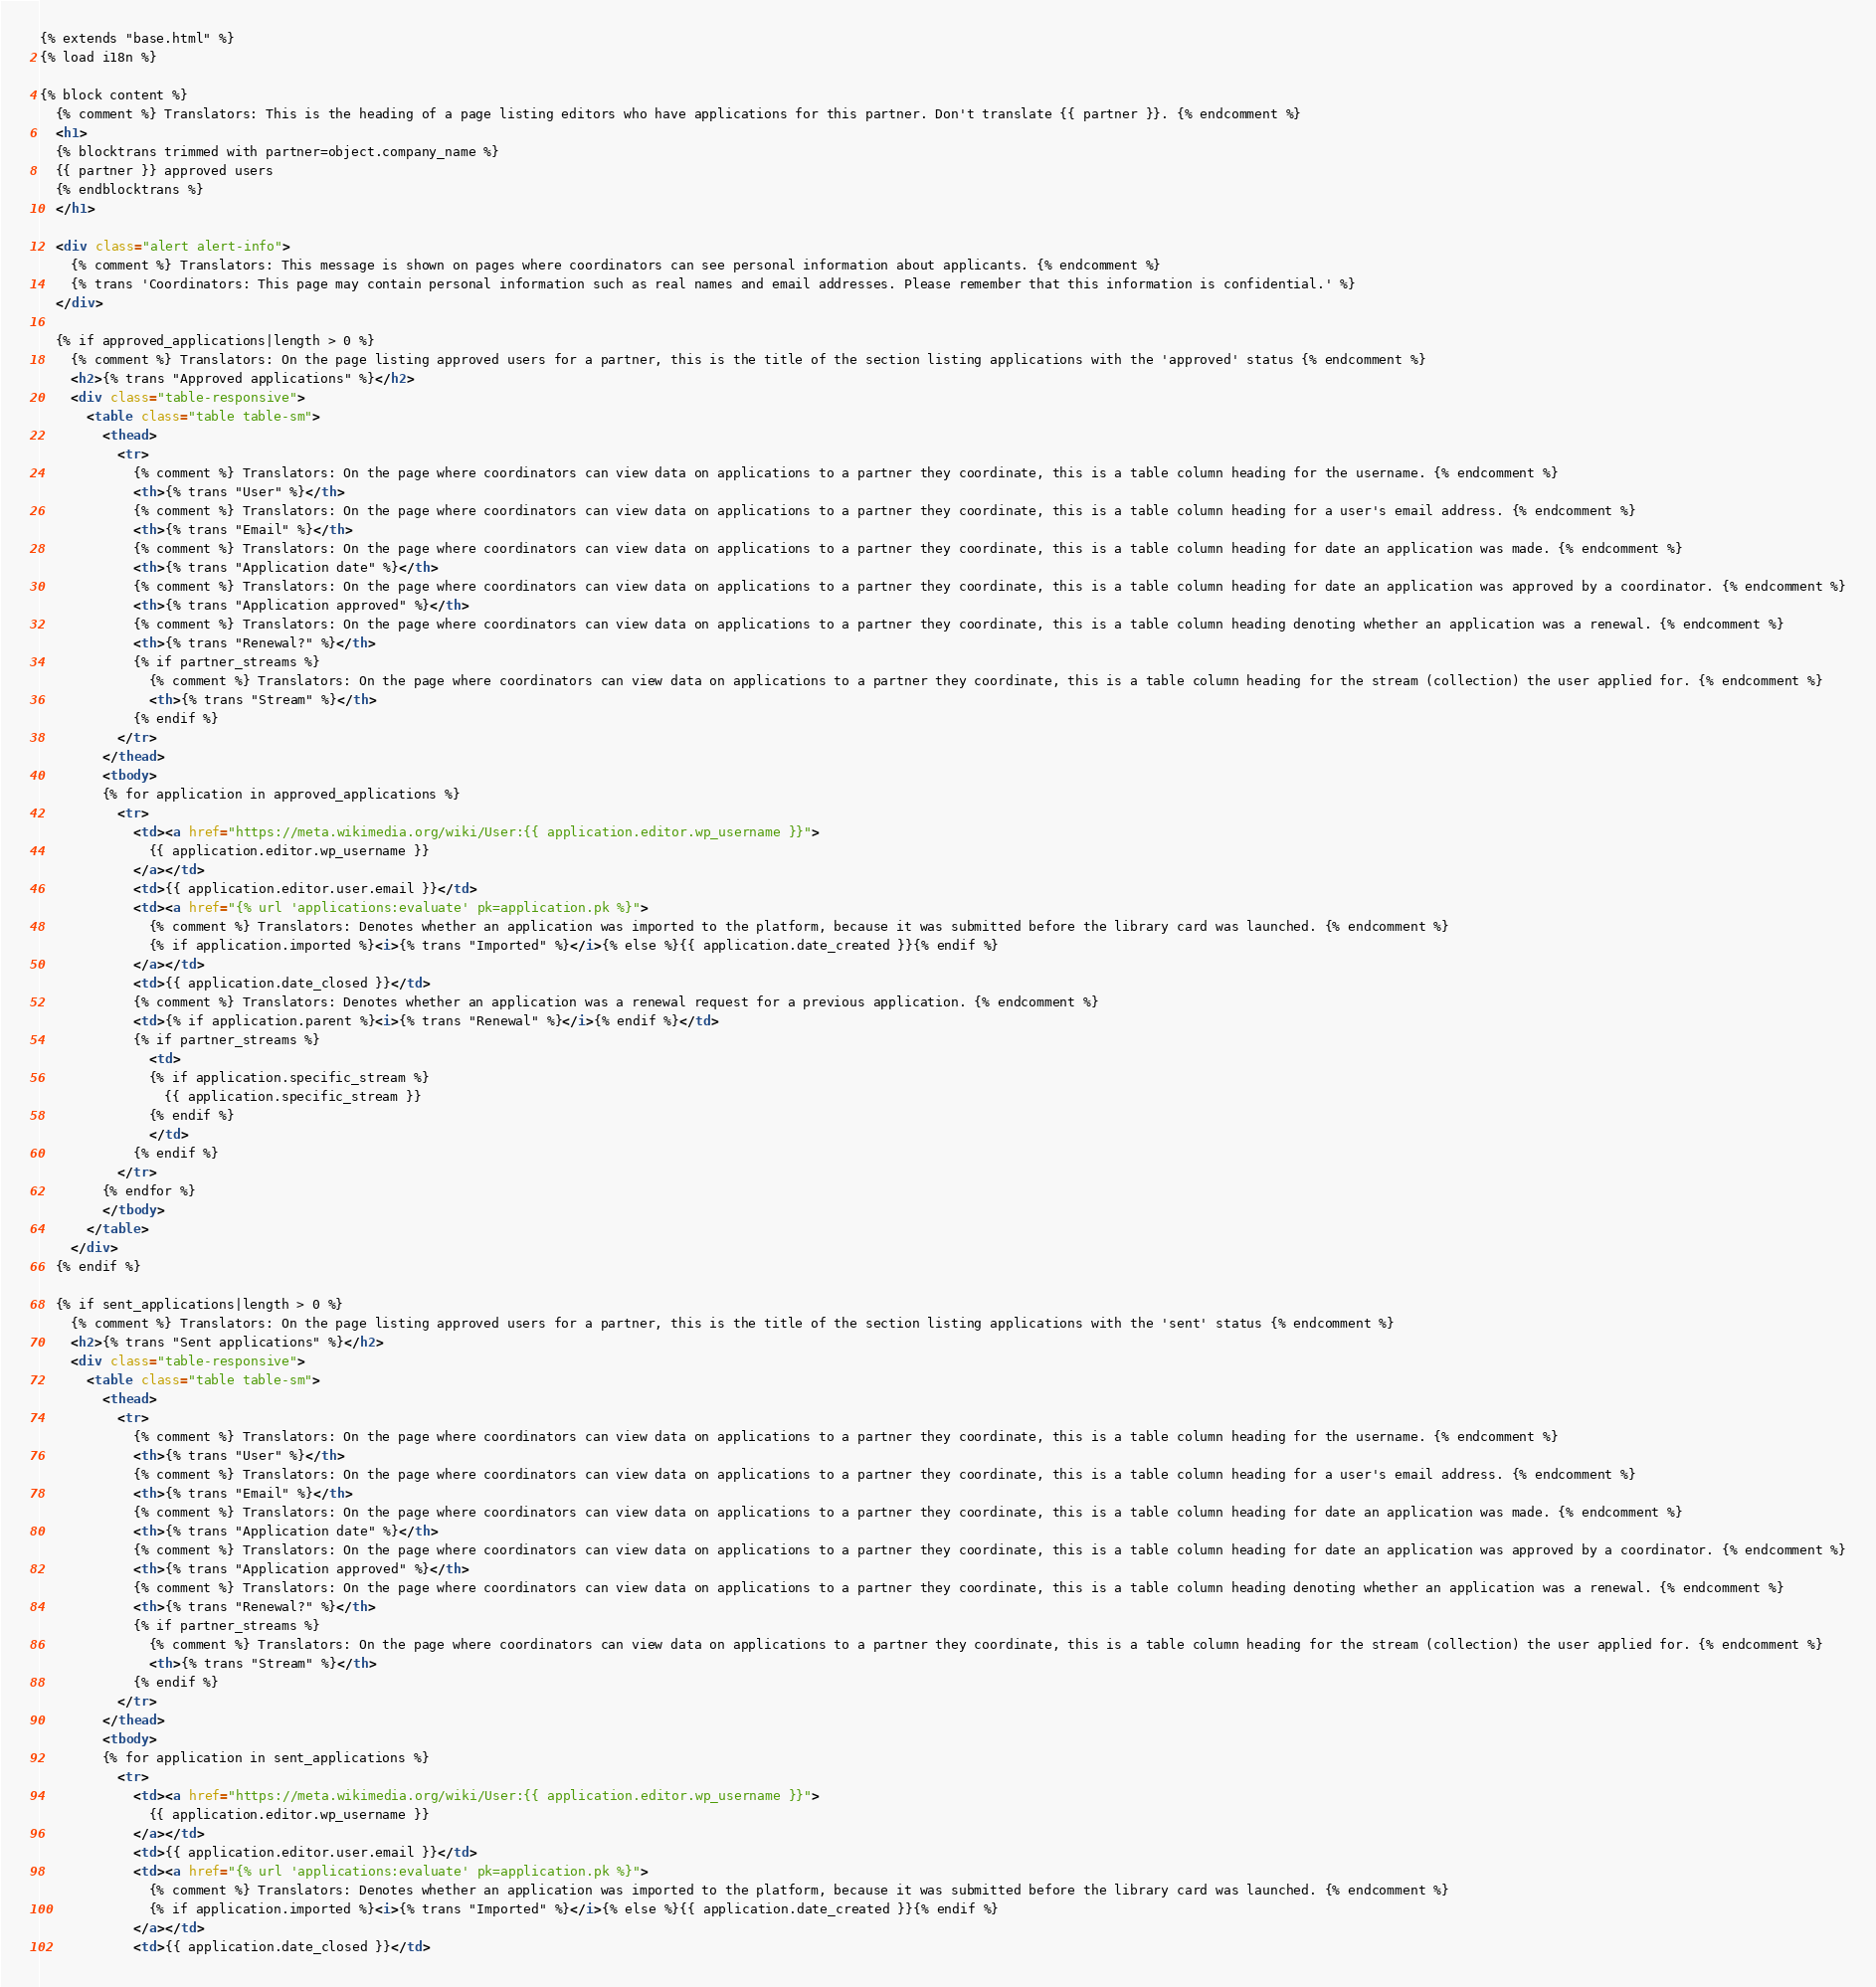Convert code to text. <code><loc_0><loc_0><loc_500><loc_500><_HTML_>{% extends "base.html" %}
{% load i18n %}

{% block content %}
  {% comment %} Translators: This is the heading of a page listing editors who have applications for this partner. Don't translate {{ partner }}. {% endcomment %}
  <h1>
  {% blocktrans trimmed with partner=object.company_name %}
  {{ partner }} approved users
  {% endblocktrans %}
  </h1>

  <div class="alert alert-info">
    {% comment %} Translators: This message is shown on pages where coordinators can see personal information about applicants. {% endcomment %}
    {% trans 'Coordinators: This page may contain personal information such as real names and email addresses. Please remember that this information is confidential.' %}
  </div>

  {% if approved_applications|length > 0 %}
    {% comment %} Translators: On the page listing approved users for a partner, this is the title of the section listing applications with the 'approved' status {% endcomment %}
    <h2>{% trans "Approved applications" %}</h2>
    <div class="table-responsive">
      <table class="table table-sm">
        <thead>
          <tr>
            {% comment %} Translators: On the page where coordinators can view data on applications to a partner they coordinate, this is a table column heading for the username. {% endcomment %}
            <th>{% trans "User" %}</th>
            {% comment %} Translators: On the page where coordinators can view data on applications to a partner they coordinate, this is a table column heading for a user's email address. {% endcomment %}
            <th>{% trans "Email" %}</th>
            {% comment %} Translators: On the page where coordinators can view data on applications to a partner they coordinate, this is a table column heading for date an application was made. {% endcomment %}
            <th>{% trans "Application date" %}</th>
            {% comment %} Translators: On the page where coordinators can view data on applications to a partner they coordinate, this is a table column heading for date an application was approved by a coordinator. {% endcomment %}
            <th>{% trans "Application approved" %}</th>
            {% comment %} Translators: On the page where coordinators can view data on applications to a partner they coordinate, this is a table column heading denoting whether an application was a renewal. {% endcomment %}
            <th>{% trans "Renewal?" %}</th>
            {% if partner_streams %}
              {% comment %} Translators: On the page where coordinators can view data on applications to a partner they coordinate, this is a table column heading for the stream (collection) the user applied for. {% endcomment %}
              <th>{% trans "Stream" %}</th>
            {% endif %}
          </tr>
        </thead>
        <tbody>
        {% for application in approved_applications %}
          <tr>
            <td><a href="https://meta.wikimedia.org/wiki/User:{{ application.editor.wp_username }}">
              {{ application.editor.wp_username }}
            </a></td>
            <td>{{ application.editor.user.email }}</td>
            <td><a href="{% url 'applications:evaluate' pk=application.pk %}">
              {% comment %} Translators: Denotes whether an application was imported to the platform, because it was submitted before the library card was launched. {% endcomment %}
              {% if application.imported %}<i>{% trans "Imported" %}</i>{% else %}{{ application.date_created }}{% endif %}
            </a></td>
            <td>{{ application.date_closed }}</td>
            {% comment %} Translators: Denotes whether an application was a renewal request for a previous application. {% endcomment %}
            <td>{% if application.parent %}<i>{% trans "Renewal" %}</i>{% endif %}</td>
            {% if partner_streams %}
              <td>
              {% if application.specific_stream %}
                {{ application.specific_stream }}
              {% endif %}
              </td>
            {% endif %}
          </tr>
        {% endfor %}
        </tbody>
      </table>
    </div>
  {% endif %}

  {% if sent_applications|length > 0 %}
    {% comment %} Translators: On the page listing approved users for a partner, this is the title of the section listing applications with the 'sent' status {% endcomment %}
    <h2>{% trans "Sent applications" %}</h2>
    <div class="table-responsive">
      <table class="table table-sm">
        <thead>
          <tr>
            {% comment %} Translators: On the page where coordinators can view data on applications to a partner they coordinate, this is a table column heading for the username. {% endcomment %}
            <th>{% trans "User" %}</th>
            {% comment %} Translators: On the page where coordinators can view data on applications to a partner they coordinate, this is a table column heading for a user's email address. {% endcomment %}
            <th>{% trans "Email" %}</th>
            {% comment %} Translators: On the page where coordinators can view data on applications to a partner they coordinate, this is a table column heading for date an application was made. {% endcomment %}
            <th>{% trans "Application date" %}</th>
            {% comment %} Translators: On the page where coordinators can view data on applications to a partner they coordinate, this is a table column heading for date an application was approved by a coordinator. {% endcomment %}
            <th>{% trans "Application approved" %}</th>
            {% comment %} Translators: On the page where coordinators can view data on applications to a partner they coordinate, this is a table column heading denoting whether an application was a renewal. {% endcomment %}
            <th>{% trans "Renewal?" %}</th>
            {% if partner_streams %}
              {% comment %} Translators: On the page where coordinators can view data on applications to a partner they coordinate, this is a table column heading for the stream (collection) the user applied for. {% endcomment %}
              <th>{% trans "Stream" %}</th>
            {% endif %}
          </tr>
        </thead>
        <tbody>
        {% for application in sent_applications %}
          <tr>
            <td><a href="https://meta.wikimedia.org/wiki/User:{{ application.editor.wp_username }}">
              {{ application.editor.wp_username }}
            </a></td>
            <td>{{ application.editor.user.email }}</td>
            <td><a href="{% url 'applications:evaluate' pk=application.pk %}">
              {% comment %} Translators: Denotes whether an application was imported to the platform, because it was submitted before the library card was launched. {% endcomment %}
              {% if application.imported %}<i>{% trans "Imported" %}</i>{% else %}{{ application.date_created }}{% endif %}
            </a></td>
            <td>{{ application.date_closed }}</td></code> 